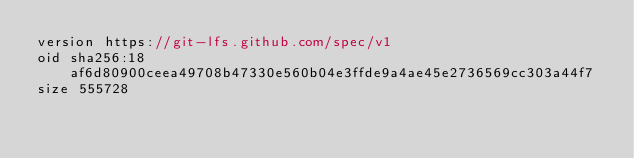<code> <loc_0><loc_0><loc_500><loc_500><_TypeScript_>version https://git-lfs.github.com/spec/v1
oid sha256:18af6d80900ceea49708b47330e560b04e3ffde9a4ae45e2736569cc303a44f7
size 555728
</code> 